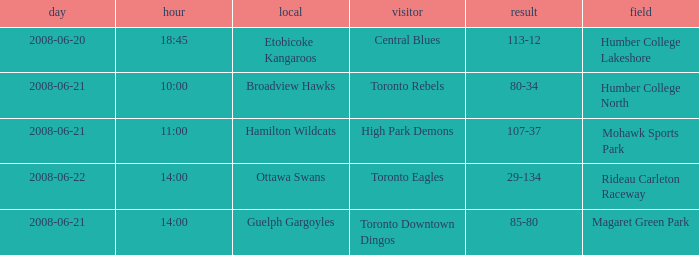What is the Ground with a Date that is 2008-06-20? Humber College Lakeshore. 